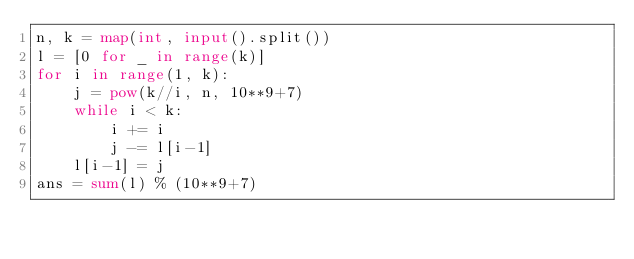Convert code to text. <code><loc_0><loc_0><loc_500><loc_500><_Python_>n, k = map(int, input().split())
l = [0 for _ in range(k)]
for i in range(1, k):
    j = pow(k//i, n, 10**9+7)
    while i < k:
        i += i
        j -= l[i-1]
    l[i-1] = j
ans = sum(l) % (10**9+7)</code> 